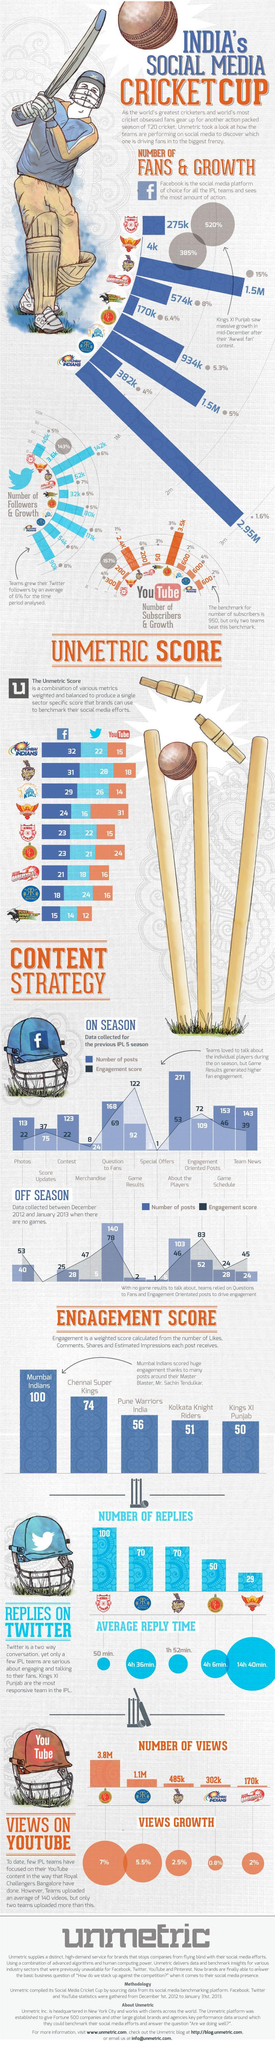How many contents have an engagement score greater than 100?
Answer the question with a short phrase. 1 Which team has the least number of Youtube Views? Delhi Daredevils What is the average reply time of Knight Riders? 1hr 52min. What is the Unmetric score of Mumbai Indians? 69 How many teams have an engagement score greater than 70? 2 What is the average reply time of Royal Challengers? 4h 6min. 